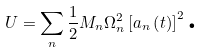<formula> <loc_0><loc_0><loc_500><loc_500>U = \sum _ { n } \frac { 1 } { 2 } M _ { n } \Omega _ { n } ^ { 2 } \left [ a _ { n } \left ( t \right ) \right ] ^ { 2 } \text {.}</formula> 